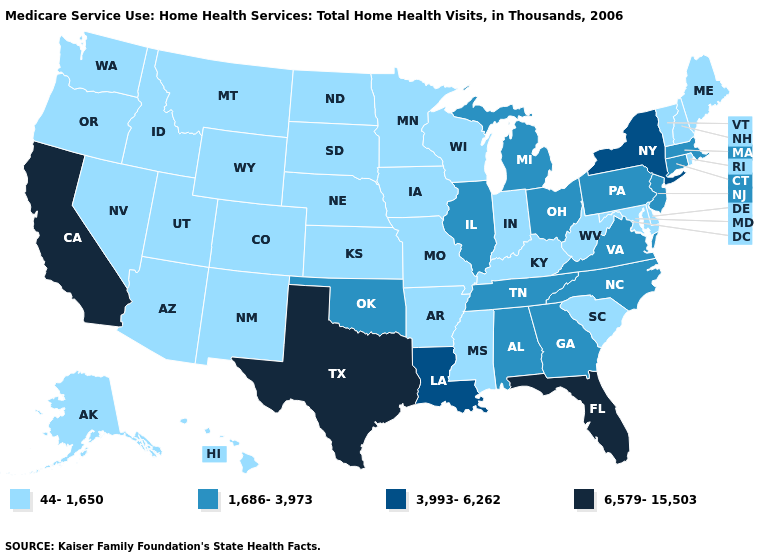What is the highest value in the MidWest ?
Write a very short answer. 1,686-3,973. Name the states that have a value in the range 6,579-15,503?
Quick response, please. California, Florida, Texas. What is the value of Georgia?
Short answer required. 1,686-3,973. What is the value of Kansas?
Concise answer only. 44-1,650. Name the states that have a value in the range 3,993-6,262?
Be succinct. Louisiana, New York. What is the value of Maine?
Write a very short answer. 44-1,650. Which states have the lowest value in the USA?
Write a very short answer. Alaska, Arizona, Arkansas, Colorado, Delaware, Hawaii, Idaho, Indiana, Iowa, Kansas, Kentucky, Maine, Maryland, Minnesota, Mississippi, Missouri, Montana, Nebraska, Nevada, New Hampshire, New Mexico, North Dakota, Oregon, Rhode Island, South Carolina, South Dakota, Utah, Vermont, Washington, West Virginia, Wisconsin, Wyoming. Does Montana have the same value as South Carolina?
Quick response, please. Yes. Does the first symbol in the legend represent the smallest category?
Quick response, please. Yes. Name the states that have a value in the range 1,686-3,973?
Keep it brief. Alabama, Connecticut, Georgia, Illinois, Massachusetts, Michigan, New Jersey, North Carolina, Ohio, Oklahoma, Pennsylvania, Tennessee, Virginia. Is the legend a continuous bar?
Quick response, please. No. What is the value of Georgia?
Give a very brief answer. 1,686-3,973. What is the highest value in the Northeast ?
Concise answer only. 3,993-6,262. Name the states that have a value in the range 3,993-6,262?
Quick response, please. Louisiana, New York. Does Ohio have the highest value in the USA?
Give a very brief answer. No. 